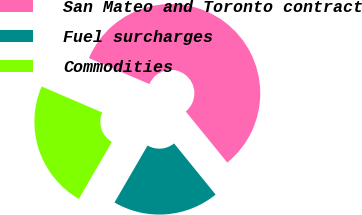Convert chart. <chart><loc_0><loc_0><loc_500><loc_500><pie_chart><fcel>San Mateo and Toronto contract<fcel>Fuel surcharges<fcel>Commodities<nl><fcel>57.69%<fcel>19.23%<fcel>23.08%<nl></chart> 